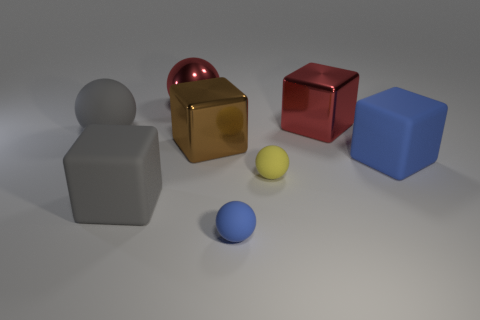There is a big object in front of the tiny yellow rubber ball; what material is it?
Your response must be concise. Rubber. Does the small blue object have the same shape as the small yellow matte thing?
Ensure brevity in your answer.  Yes. What is the color of the other shiny thing that is the same shape as the brown shiny thing?
Ensure brevity in your answer.  Red. Are there more objects that are left of the red block than red objects?
Provide a succinct answer. Yes. There is a large matte cube right of the gray block; what is its color?
Your answer should be compact. Blue. Is the brown block the same size as the yellow ball?
Ensure brevity in your answer.  No. The yellow matte sphere is what size?
Offer a terse response. Small. There is a shiny thing that is the same color as the shiny sphere; what is its shape?
Provide a short and direct response. Cube. Is the number of big gray rubber cubes greater than the number of small balls?
Offer a terse response. No. The small sphere in front of the yellow rubber object that is left of the metal cube that is behind the gray matte sphere is what color?
Your response must be concise. Blue. 